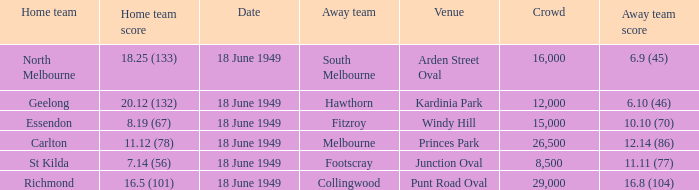What is the away team score when home team score is 20.12 (132)? 6.10 (46). 